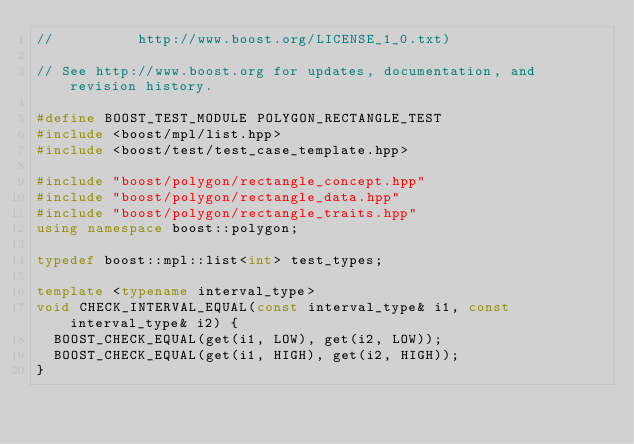<code> <loc_0><loc_0><loc_500><loc_500><_C++_>//          http://www.boost.org/LICENSE_1_0.txt)

// See http://www.boost.org for updates, documentation, and revision history.

#define BOOST_TEST_MODULE POLYGON_RECTANGLE_TEST
#include <boost/mpl/list.hpp>
#include <boost/test/test_case_template.hpp>

#include "boost/polygon/rectangle_concept.hpp"
#include "boost/polygon/rectangle_data.hpp"
#include "boost/polygon/rectangle_traits.hpp"
using namespace boost::polygon;

typedef boost::mpl::list<int> test_types;

template <typename interval_type>
void CHECK_INTERVAL_EQUAL(const interval_type& i1, const interval_type& i2) {
  BOOST_CHECK_EQUAL(get(i1, LOW), get(i2, LOW));
  BOOST_CHECK_EQUAL(get(i1, HIGH), get(i2, HIGH));
}
</code> 